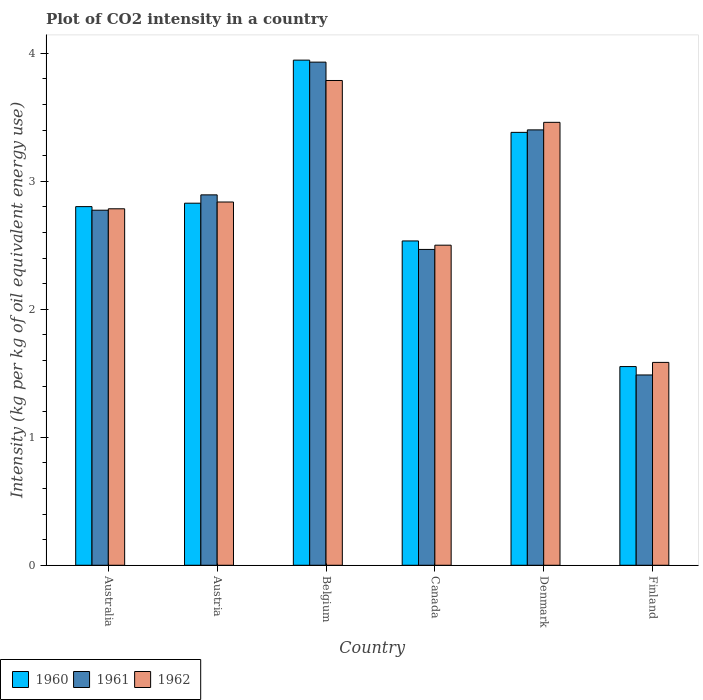Are the number of bars on each tick of the X-axis equal?
Your answer should be very brief. Yes. How many bars are there on the 1st tick from the left?
Your answer should be compact. 3. What is the label of the 5th group of bars from the left?
Provide a succinct answer. Denmark. In how many cases, is the number of bars for a given country not equal to the number of legend labels?
Offer a very short reply. 0. What is the CO2 intensity in in 1961 in Denmark?
Offer a terse response. 3.4. Across all countries, what is the maximum CO2 intensity in in 1962?
Provide a short and direct response. 3.79. Across all countries, what is the minimum CO2 intensity in in 1960?
Make the answer very short. 1.55. In which country was the CO2 intensity in in 1961 maximum?
Provide a succinct answer. Belgium. What is the total CO2 intensity in in 1962 in the graph?
Give a very brief answer. 16.95. What is the difference between the CO2 intensity in in 1962 in Belgium and that in Canada?
Offer a very short reply. 1.29. What is the difference between the CO2 intensity in in 1960 in Australia and the CO2 intensity in in 1961 in Canada?
Make the answer very short. 0.33. What is the average CO2 intensity in in 1961 per country?
Ensure brevity in your answer.  2.83. What is the difference between the CO2 intensity in of/in 1961 and CO2 intensity in of/in 1962 in Belgium?
Your response must be concise. 0.14. In how many countries, is the CO2 intensity in in 1961 greater than 0.6000000000000001 kg?
Provide a succinct answer. 6. What is the ratio of the CO2 intensity in in 1960 in Canada to that in Finland?
Offer a terse response. 1.63. Is the CO2 intensity in in 1962 in Australia less than that in Belgium?
Offer a very short reply. Yes. What is the difference between the highest and the second highest CO2 intensity in in 1962?
Provide a succinct answer. 0.62. What is the difference between the highest and the lowest CO2 intensity in in 1961?
Ensure brevity in your answer.  2.44. Is the sum of the CO2 intensity in in 1962 in Austria and Finland greater than the maximum CO2 intensity in in 1960 across all countries?
Your answer should be compact. Yes. What does the 1st bar from the left in Australia represents?
Your answer should be compact. 1960. What does the 3rd bar from the right in Finland represents?
Give a very brief answer. 1960. Is it the case that in every country, the sum of the CO2 intensity in in 1962 and CO2 intensity in in 1961 is greater than the CO2 intensity in in 1960?
Keep it short and to the point. Yes. Are all the bars in the graph horizontal?
Your response must be concise. No. What is the difference between two consecutive major ticks on the Y-axis?
Your answer should be compact. 1. Are the values on the major ticks of Y-axis written in scientific E-notation?
Your response must be concise. No. Does the graph contain any zero values?
Your answer should be compact. No. Where does the legend appear in the graph?
Keep it short and to the point. Bottom left. How many legend labels are there?
Offer a terse response. 3. How are the legend labels stacked?
Make the answer very short. Horizontal. What is the title of the graph?
Your answer should be compact. Plot of CO2 intensity in a country. Does "1968" appear as one of the legend labels in the graph?
Offer a terse response. No. What is the label or title of the X-axis?
Provide a short and direct response. Country. What is the label or title of the Y-axis?
Ensure brevity in your answer.  Intensity (kg per kg of oil equivalent energy use). What is the Intensity (kg per kg of oil equivalent energy use) in 1960 in Australia?
Your answer should be very brief. 2.8. What is the Intensity (kg per kg of oil equivalent energy use) of 1961 in Australia?
Keep it short and to the point. 2.77. What is the Intensity (kg per kg of oil equivalent energy use) of 1962 in Australia?
Your answer should be compact. 2.78. What is the Intensity (kg per kg of oil equivalent energy use) in 1960 in Austria?
Keep it short and to the point. 2.83. What is the Intensity (kg per kg of oil equivalent energy use) in 1961 in Austria?
Give a very brief answer. 2.89. What is the Intensity (kg per kg of oil equivalent energy use) of 1962 in Austria?
Offer a very short reply. 2.84. What is the Intensity (kg per kg of oil equivalent energy use) in 1960 in Belgium?
Offer a very short reply. 3.95. What is the Intensity (kg per kg of oil equivalent energy use) in 1961 in Belgium?
Your response must be concise. 3.93. What is the Intensity (kg per kg of oil equivalent energy use) of 1962 in Belgium?
Provide a short and direct response. 3.79. What is the Intensity (kg per kg of oil equivalent energy use) in 1960 in Canada?
Your answer should be compact. 2.53. What is the Intensity (kg per kg of oil equivalent energy use) of 1961 in Canada?
Your answer should be compact. 2.47. What is the Intensity (kg per kg of oil equivalent energy use) in 1962 in Canada?
Your response must be concise. 2.5. What is the Intensity (kg per kg of oil equivalent energy use) in 1960 in Denmark?
Your answer should be compact. 3.38. What is the Intensity (kg per kg of oil equivalent energy use) in 1961 in Denmark?
Make the answer very short. 3.4. What is the Intensity (kg per kg of oil equivalent energy use) of 1962 in Denmark?
Provide a short and direct response. 3.46. What is the Intensity (kg per kg of oil equivalent energy use) in 1960 in Finland?
Ensure brevity in your answer.  1.55. What is the Intensity (kg per kg of oil equivalent energy use) in 1961 in Finland?
Give a very brief answer. 1.49. What is the Intensity (kg per kg of oil equivalent energy use) of 1962 in Finland?
Offer a terse response. 1.58. Across all countries, what is the maximum Intensity (kg per kg of oil equivalent energy use) of 1960?
Keep it short and to the point. 3.95. Across all countries, what is the maximum Intensity (kg per kg of oil equivalent energy use) in 1961?
Keep it short and to the point. 3.93. Across all countries, what is the maximum Intensity (kg per kg of oil equivalent energy use) in 1962?
Offer a terse response. 3.79. Across all countries, what is the minimum Intensity (kg per kg of oil equivalent energy use) in 1960?
Your answer should be very brief. 1.55. Across all countries, what is the minimum Intensity (kg per kg of oil equivalent energy use) of 1961?
Keep it short and to the point. 1.49. Across all countries, what is the minimum Intensity (kg per kg of oil equivalent energy use) of 1962?
Offer a terse response. 1.58. What is the total Intensity (kg per kg of oil equivalent energy use) in 1960 in the graph?
Offer a terse response. 17.04. What is the total Intensity (kg per kg of oil equivalent energy use) of 1961 in the graph?
Offer a very short reply. 16.95. What is the total Intensity (kg per kg of oil equivalent energy use) in 1962 in the graph?
Provide a short and direct response. 16.95. What is the difference between the Intensity (kg per kg of oil equivalent energy use) in 1960 in Australia and that in Austria?
Offer a very short reply. -0.03. What is the difference between the Intensity (kg per kg of oil equivalent energy use) of 1961 in Australia and that in Austria?
Give a very brief answer. -0.12. What is the difference between the Intensity (kg per kg of oil equivalent energy use) of 1962 in Australia and that in Austria?
Your answer should be compact. -0.05. What is the difference between the Intensity (kg per kg of oil equivalent energy use) in 1960 in Australia and that in Belgium?
Ensure brevity in your answer.  -1.14. What is the difference between the Intensity (kg per kg of oil equivalent energy use) of 1961 in Australia and that in Belgium?
Give a very brief answer. -1.16. What is the difference between the Intensity (kg per kg of oil equivalent energy use) of 1962 in Australia and that in Belgium?
Provide a succinct answer. -1. What is the difference between the Intensity (kg per kg of oil equivalent energy use) of 1960 in Australia and that in Canada?
Offer a terse response. 0.27. What is the difference between the Intensity (kg per kg of oil equivalent energy use) in 1961 in Australia and that in Canada?
Keep it short and to the point. 0.31. What is the difference between the Intensity (kg per kg of oil equivalent energy use) of 1962 in Australia and that in Canada?
Ensure brevity in your answer.  0.28. What is the difference between the Intensity (kg per kg of oil equivalent energy use) of 1960 in Australia and that in Denmark?
Offer a very short reply. -0.58. What is the difference between the Intensity (kg per kg of oil equivalent energy use) of 1961 in Australia and that in Denmark?
Your response must be concise. -0.63. What is the difference between the Intensity (kg per kg of oil equivalent energy use) in 1962 in Australia and that in Denmark?
Offer a terse response. -0.68. What is the difference between the Intensity (kg per kg of oil equivalent energy use) in 1960 in Australia and that in Finland?
Ensure brevity in your answer.  1.25. What is the difference between the Intensity (kg per kg of oil equivalent energy use) in 1961 in Australia and that in Finland?
Offer a terse response. 1.29. What is the difference between the Intensity (kg per kg of oil equivalent energy use) of 1960 in Austria and that in Belgium?
Provide a short and direct response. -1.12. What is the difference between the Intensity (kg per kg of oil equivalent energy use) of 1961 in Austria and that in Belgium?
Provide a short and direct response. -1.04. What is the difference between the Intensity (kg per kg of oil equivalent energy use) of 1962 in Austria and that in Belgium?
Offer a terse response. -0.95. What is the difference between the Intensity (kg per kg of oil equivalent energy use) of 1960 in Austria and that in Canada?
Ensure brevity in your answer.  0.29. What is the difference between the Intensity (kg per kg of oil equivalent energy use) in 1961 in Austria and that in Canada?
Provide a short and direct response. 0.43. What is the difference between the Intensity (kg per kg of oil equivalent energy use) in 1962 in Austria and that in Canada?
Your answer should be very brief. 0.34. What is the difference between the Intensity (kg per kg of oil equivalent energy use) in 1960 in Austria and that in Denmark?
Offer a terse response. -0.55. What is the difference between the Intensity (kg per kg of oil equivalent energy use) in 1961 in Austria and that in Denmark?
Offer a very short reply. -0.51. What is the difference between the Intensity (kg per kg of oil equivalent energy use) in 1962 in Austria and that in Denmark?
Give a very brief answer. -0.62. What is the difference between the Intensity (kg per kg of oil equivalent energy use) in 1960 in Austria and that in Finland?
Your answer should be compact. 1.28. What is the difference between the Intensity (kg per kg of oil equivalent energy use) of 1961 in Austria and that in Finland?
Ensure brevity in your answer.  1.41. What is the difference between the Intensity (kg per kg of oil equivalent energy use) in 1962 in Austria and that in Finland?
Offer a very short reply. 1.25. What is the difference between the Intensity (kg per kg of oil equivalent energy use) of 1960 in Belgium and that in Canada?
Ensure brevity in your answer.  1.41. What is the difference between the Intensity (kg per kg of oil equivalent energy use) of 1961 in Belgium and that in Canada?
Give a very brief answer. 1.46. What is the difference between the Intensity (kg per kg of oil equivalent energy use) in 1962 in Belgium and that in Canada?
Provide a short and direct response. 1.29. What is the difference between the Intensity (kg per kg of oil equivalent energy use) of 1960 in Belgium and that in Denmark?
Keep it short and to the point. 0.56. What is the difference between the Intensity (kg per kg of oil equivalent energy use) in 1961 in Belgium and that in Denmark?
Your response must be concise. 0.53. What is the difference between the Intensity (kg per kg of oil equivalent energy use) in 1962 in Belgium and that in Denmark?
Offer a very short reply. 0.33. What is the difference between the Intensity (kg per kg of oil equivalent energy use) of 1960 in Belgium and that in Finland?
Your answer should be compact. 2.39. What is the difference between the Intensity (kg per kg of oil equivalent energy use) of 1961 in Belgium and that in Finland?
Your answer should be very brief. 2.44. What is the difference between the Intensity (kg per kg of oil equivalent energy use) in 1962 in Belgium and that in Finland?
Ensure brevity in your answer.  2.2. What is the difference between the Intensity (kg per kg of oil equivalent energy use) of 1960 in Canada and that in Denmark?
Your answer should be compact. -0.85. What is the difference between the Intensity (kg per kg of oil equivalent energy use) in 1961 in Canada and that in Denmark?
Your answer should be very brief. -0.93. What is the difference between the Intensity (kg per kg of oil equivalent energy use) of 1962 in Canada and that in Denmark?
Provide a short and direct response. -0.96. What is the difference between the Intensity (kg per kg of oil equivalent energy use) in 1960 in Canada and that in Finland?
Provide a short and direct response. 0.98. What is the difference between the Intensity (kg per kg of oil equivalent energy use) of 1961 in Canada and that in Finland?
Keep it short and to the point. 0.98. What is the difference between the Intensity (kg per kg of oil equivalent energy use) in 1962 in Canada and that in Finland?
Ensure brevity in your answer.  0.92. What is the difference between the Intensity (kg per kg of oil equivalent energy use) in 1960 in Denmark and that in Finland?
Your answer should be compact. 1.83. What is the difference between the Intensity (kg per kg of oil equivalent energy use) of 1961 in Denmark and that in Finland?
Your answer should be very brief. 1.91. What is the difference between the Intensity (kg per kg of oil equivalent energy use) in 1962 in Denmark and that in Finland?
Give a very brief answer. 1.88. What is the difference between the Intensity (kg per kg of oil equivalent energy use) in 1960 in Australia and the Intensity (kg per kg of oil equivalent energy use) in 1961 in Austria?
Your response must be concise. -0.09. What is the difference between the Intensity (kg per kg of oil equivalent energy use) of 1960 in Australia and the Intensity (kg per kg of oil equivalent energy use) of 1962 in Austria?
Make the answer very short. -0.04. What is the difference between the Intensity (kg per kg of oil equivalent energy use) in 1961 in Australia and the Intensity (kg per kg of oil equivalent energy use) in 1962 in Austria?
Your answer should be compact. -0.06. What is the difference between the Intensity (kg per kg of oil equivalent energy use) of 1960 in Australia and the Intensity (kg per kg of oil equivalent energy use) of 1961 in Belgium?
Make the answer very short. -1.13. What is the difference between the Intensity (kg per kg of oil equivalent energy use) of 1960 in Australia and the Intensity (kg per kg of oil equivalent energy use) of 1962 in Belgium?
Provide a short and direct response. -0.99. What is the difference between the Intensity (kg per kg of oil equivalent energy use) of 1961 in Australia and the Intensity (kg per kg of oil equivalent energy use) of 1962 in Belgium?
Offer a very short reply. -1.01. What is the difference between the Intensity (kg per kg of oil equivalent energy use) in 1960 in Australia and the Intensity (kg per kg of oil equivalent energy use) in 1961 in Canada?
Provide a short and direct response. 0.33. What is the difference between the Intensity (kg per kg of oil equivalent energy use) of 1960 in Australia and the Intensity (kg per kg of oil equivalent energy use) of 1962 in Canada?
Your answer should be very brief. 0.3. What is the difference between the Intensity (kg per kg of oil equivalent energy use) in 1961 in Australia and the Intensity (kg per kg of oil equivalent energy use) in 1962 in Canada?
Your answer should be very brief. 0.27. What is the difference between the Intensity (kg per kg of oil equivalent energy use) in 1960 in Australia and the Intensity (kg per kg of oil equivalent energy use) in 1961 in Denmark?
Offer a terse response. -0.6. What is the difference between the Intensity (kg per kg of oil equivalent energy use) in 1960 in Australia and the Intensity (kg per kg of oil equivalent energy use) in 1962 in Denmark?
Ensure brevity in your answer.  -0.66. What is the difference between the Intensity (kg per kg of oil equivalent energy use) of 1961 in Australia and the Intensity (kg per kg of oil equivalent energy use) of 1962 in Denmark?
Ensure brevity in your answer.  -0.69. What is the difference between the Intensity (kg per kg of oil equivalent energy use) in 1960 in Australia and the Intensity (kg per kg of oil equivalent energy use) in 1961 in Finland?
Keep it short and to the point. 1.32. What is the difference between the Intensity (kg per kg of oil equivalent energy use) of 1960 in Australia and the Intensity (kg per kg of oil equivalent energy use) of 1962 in Finland?
Offer a terse response. 1.22. What is the difference between the Intensity (kg per kg of oil equivalent energy use) in 1961 in Australia and the Intensity (kg per kg of oil equivalent energy use) in 1962 in Finland?
Make the answer very short. 1.19. What is the difference between the Intensity (kg per kg of oil equivalent energy use) in 1960 in Austria and the Intensity (kg per kg of oil equivalent energy use) in 1961 in Belgium?
Keep it short and to the point. -1.1. What is the difference between the Intensity (kg per kg of oil equivalent energy use) in 1960 in Austria and the Intensity (kg per kg of oil equivalent energy use) in 1962 in Belgium?
Your answer should be very brief. -0.96. What is the difference between the Intensity (kg per kg of oil equivalent energy use) in 1961 in Austria and the Intensity (kg per kg of oil equivalent energy use) in 1962 in Belgium?
Your answer should be very brief. -0.89. What is the difference between the Intensity (kg per kg of oil equivalent energy use) of 1960 in Austria and the Intensity (kg per kg of oil equivalent energy use) of 1961 in Canada?
Ensure brevity in your answer.  0.36. What is the difference between the Intensity (kg per kg of oil equivalent energy use) of 1960 in Austria and the Intensity (kg per kg of oil equivalent energy use) of 1962 in Canada?
Your response must be concise. 0.33. What is the difference between the Intensity (kg per kg of oil equivalent energy use) of 1961 in Austria and the Intensity (kg per kg of oil equivalent energy use) of 1962 in Canada?
Offer a terse response. 0.39. What is the difference between the Intensity (kg per kg of oil equivalent energy use) in 1960 in Austria and the Intensity (kg per kg of oil equivalent energy use) in 1961 in Denmark?
Your answer should be compact. -0.57. What is the difference between the Intensity (kg per kg of oil equivalent energy use) in 1960 in Austria and the Intensity (kg per kg of oil equivalent energy use) in 1962 in Denmark?
Provide a short and direct response. -0.63. What is the difference between the Intensity (kg per kg of oil equivalent energy use) of 1961 in Austria and the Intensity (kg per kg of oil equivalent energy use) of 1962 in Denmark?
Your answer should be very brief. -0.57. What is the difference between the Intensity (kg per kg of oil equivalent energy use) of 1960 in Austria and the Intensity (kg per kg of oil equivalent energy use) of 1961 in Finland?
Ensure brevity in your answer.  1.34. What is the difference between the Intensity (kg per kg of oil equivalent energy use) of 1960 in Austria and the Intensity (kg per kg of oil equivalent energy use) of 1962 in Finland?
Provide a succinct answer. 1.24. What is the difference between the Intensity (kg per kg of oil equivalent energy use) of 1961 in Austria and the Intensity (kg per kg of oil equivalent energy use) of 1962 in Finland?
Make the answer very short. 1.31. What is the difference between the Intensity (kg per kg of oil equivalent energy use) in 1960 in Belgium and the Intensity (kg per kg of oil equivalent energy use) in 1961 in Canada?
Ensure brevity in your answer.  1.48. What is the difference between the Intensity (kg per kg of oil equivalent energy use) of 1960 in Belgium and the Intensity (kg per kg of oil equivalent energy use) of 1962 in Canada?
Make the answer very short. 1.45. What is the difference between the Intensity (kg per kg of oil equivalent energy use) in 1961 in Belgium and the Intensity (kg per kg of oil equivalent energy use) in 1962 in Canada?
Your answer should be compact. 1.43. What is the difference between the Intensity (kg per kg of oil equivalent energy use) in 1960 in Belgium and the Intensity (kg per kg of oil equivalent energy use) in 1961 in Denmark?
Provide a short and direct response. 0.54. What is the difference between the Intensity (kg per kg of oil equivalent energy use) in 1960 in Belgium and the Intensity (kg per kg of oil equivalent energy use) in 1962 in Denmark?
Make the answer very short. 0.49. What is the difference between the Intensity (kg per kg of oil equivalent energy use) in 1961 in Belgium and the Intensity (kg per kg of oil equivalent energy use) in 1962 in Denmark?
Give a very brief answer. 0.47. What is the difference between the Intensity (kg per kg of oil equivalent energy use) of 1960 in Belgium and the Intensity (kg per kg of oil equivalent energy use) of 1961 in Finland?
Offer a terse response. 2.46. What is the difference between the Intensity (kg per kg of oil equivalent energy use) in 1960 in Belgium and the Intensity (kg per kg of oil equivalent energy use) in 1962 in Finland?
Your answer should be compact. 2.36. What is the difference between the Intensity (kg per kg of oil equivalent energy use) of 1961 in Belgium and the Intensity (kg per kg of oil equivalent energy use) of 1962 in Finland?
Your answer should be very brief. 2.35. What is the difference between the Intensity (kg per kg of oil equivalent energy use) of 1960 in Canada and the Intensity (kg per kg of oil equivalent energy use) of 1961 in Denmark?
Your answer should be compact. -0.87. What is the difference between the Intensity (kg per kg of oil equivalent energy use) of 1960 in Canada and the Intensity (kg per kg of oil equivalent energy use) of 1962 in Denmark?
Give a very brief answer. -0.93. What is the difference between the Intensity (kg per kg of oil equivalent energy use) in 1961 in Canada and the Intensity (kg per kg of oil equivalent energy use) in 1962 in Denmark?
Your response must be concise. -0.99. What is the difference between the Intensity (kg per kg of oil equivalent energy use) of 1960 in Canada and the Intensity (kg per kg of oil equivalent energy use) of 1961 in Finland?
Keep it short and to the point. 1.05. What is the difference between the Intensity (kg per kg of oil equivalent energy use) of 1960 in Canada and the Intensity (kg per kg of oil equivalent energy use) of 1962 in Finland?
Your answer should be compact. 0.95. What is the difference between the Intensity (kg per kg of oil equivalent energy use) of 1961 in Canada and the Intensity (kg per kg of oil equivalent energy use) of 1962 in Finland?
Provide a short and direct response. 0.88. What is the difference between the Intensity (kg per kg of oil equivalent energy use) in 1960 in Denmark and the Intensity (kg per kg of oil equivalent energy use) in 1961 in Finland?
Give a very brief answer. 1.9. What is the difference between the Intensity (kg per kg of oil equivalent energy use) in 1960 in Denmark and the Intensity (kg per kg of oil equivalent energy use) in 1962 in Finland?
Your answer should be compact. 1.8. What is the difference between the Intensity (kg per kg of oil equivalent energy use) in 1961 in Denmark and the Intensity (kg per kg of oil equivalent energy use) in 1962 in Finland?
Your response must be concise. 1.82. What is the average Intensity (kg per kg of oil equivalent energy use) in 1960 per country?
Give a very brief answer. 2.84. What is the average Intensity (kg per kg of oil equivalent energy use) of 1961 per country?
Ensure brevity in your answer.  2.83. What is the average Intensity (kg per kg of oil equivalent energy use) of 1962 per country?
Keep it short and to the point. 2.83. What is the difference between the Intensity (kg per kg of oil equivalent energy use) of 1960 and Intensity (kg per kg of oil equivalent energy use) of 1961 in Australia?
Give a very brief answer. 0.03. What is the difference between the Intensity (kg per kg of oil equivalent energy use) in 1960 and Intensity (kg per kg of oil equivalent energy use) in 1962 in Australia?
Offer a very short reply. 0.02. What is the difference between the Intensity (kg per kg of oil equivalent energy use) of 1961 and Intensity (kg per kg of oil equivalent energy use) of 1962 in Australia?
Make the answer very short. -0.01. What is the difference between the Intensity (kg per kg of oil equivalent energy use) of 1960 and Intensity (kg per kg of oil equivalent energy use) of 1961 in Austria?
Offer a terse response. -0.07. What is the difference between the Intensity (kg per kg of oil equivalent energy use) in 1960 and Intensity (kg per kg of oil equivalent energy use) in 1962 in Austria?
Make the answer very short. -0.01. What is the difference between the Intensity (kg per kg of oil equivalent energy use) in 1961 and Intensity (kg per kg of oil equivalent energy use) in 1962 in Austria?
Your answer should be compact. 0.06. What is the difference between the Intensity (kg per kg of oil equivalent energy use) in 1960 and Intensity (kg per kg of oil equivalent energy use) in 1961 in Belgium?
Your answer should be compact. 0.02. What is the difference between the Intensity (kg per kg of oil equivalent energy use) in 1960 and Intensity (kg per kg of oil equivalent energy use) in 1962 in Belgium?
Provide a succinct answer. 0.16. What is the difference between the Intensity (kg per kg of oil equivalent energy use) in 1961 and Intensity (kg per kg of oil equivalent energy use) in 1962 in Belgium?
Keep it short and to the point. 0.14. What is the difference between the Intensity (kg per kg of oil equivalent energy use) in 1960 and Intensity (kg per kg of oil equivalent energy use) in 1961 in Canada?
Make the answer very short. 0.07. What is the difference between the Intensity (kg per kg of oil equivalent energy use) in 1960 and Intensity (kg per kg of oil equivalent energy use) in 1962 in Canada?
Offer a very short reply. 0.03. What is the difference between the Intensity (kg per kg of oil equivalent energy use) in 1961 and Intensity (kg per kg of oil equivalent energy use) in 1962 in Canada?
Your answer should be compact. -0.03. What is the difference between the Intensity (kg per kg of oil equivalent energy use) in 1960 and Intensity (kg per kg of oil equivalent energy use) in 1961 in Denmark?
Your answer should be very brief. -0.02. What is the difference between the Intensity (kg per kg of oil equivalent energy use) in 1960 and Intensity (kg per kg of oil equivalent energy use) in 1962 in Denmark?
Offer a terse response. -0.08. What is the difference between the Intensity (kg per kg of oil equivalent energy use) in 1961 and Intensity (kg per kg of oil equivalent energy use) in 1962 in Denmark?
Offer a terse response. -0.06. What is the difference between the Intensity (kg per kg of oil equivalent energy use) of 1960 and Intensity (kg per kg of oil equivalent energy use) of 1961 in Finland?
Provide a short and direct response. 0.07. What is the difference between the Intensity (kg per kg of oil equivalent energy use) in 1960 and Intensity (kg per kg of oil equivalent energy use) in 1962 in Finland?
Offer a very short reply. -0.03. What is the difference between the Intensity (kg per kg of oil equivalent energy use) of 1961 and Intensity (kg per kg of oil equivalent energy use) of 1962 in Finland?
Offer a terse response. -0.1. What is the ratio of the Intensity (kg per kg of oil equivalent energy use) of 1960 in Australia to that in Austria?
Provide a succinct answer. 0.99. What is the ratio of the Intensity (kg per kg of oil equivalent energy use) in 1961 in Australia to that in Austria?
Give a very brief answer. 0.96. What is the ratio of the Intensity (kg per kg of oil equivalent energy use) of 1962 in Australia to that in Austria?
Make the answer very short. 0.98. What is the ratio of the Intensity (kg per kg of oil equivalent energy use) of 1960 in Australia to that in Belgium?
Offer a terse response. 0.71. What is the ratio of the Intensity (kg per kg of oil equivalent energy use) in 1961 in Australia to that in Belgium?
Offer a terse response. 0.71. What is the ratio of the Intensity (kg per kg of oil equivalent energy use) in 1962 in Australia to that in Belgium?
Offer a terse response. 0.74. What is the ratio of the Intensity (kg per kg of oil equivalent energy use) of 1960 in Australia to that in Canada?
Your answer should be compact. 1.11. What is the ratio of the Intensity (kg per kg of oil equivalent energy use) of 1961 in Australia to that in Canada?
Make the answer very short. 1.12. What is the ratio of the Intensity (kg per kg of oil equivalent energy use) of 1962 in Australia to that in Canada?
Give a very brief answer. 1.11. What is the ratio of the Intensity (kg per kg of oil equivalent energy use) in 1960 in Australia to that in Denmark?
Your response must be concise. 0.83. What is the ratio of the Intensity (kg per kg of oil equivalent energy use) of 1961 in Australia to that in Denmark?
Provide a short and direct response. 0.82. What is the ratio of the Intensity (kg per kg of oil equivalent energy use) of 1962 in Australia to that in Denmark?
Your response must be concise. 0.8. What is the ratio of the Intensity (kg per kg of oil equivalent energy use) of 1960 in Australia to that in Finland?
Your answer should be very brief. 1.81. What is the ratio of the Intensity (kg per kg of oil equivalent energy use) of 1961 in Australia to that in Finland?
Give a very brief answer. 1.87. What is the ratio of the Intensity (kg per kg of oil equivalent energy use) in 1962 in Australia to that in Finland?
Offer a very short reply. 1.76. What is the ratio of the Intensity (kg per kg of oil equivalent energy use) of 1960 in Austria to that in Belgium?
Give a very brief answer. 0.72. What is the ratio of the Intensity (kg per kg of oil equivalent energy use) in 1961 in Austria to that in Belgium?
Offer a very short reply. 0.74. What is the ratio of the Intensity (kg per kg of oil equivalent energy use) of 1962 in Austria to that in Belgium?
Your answer should be very brief. 0.75. What is the ratio of the Intensity (kg per kg of oil equivalent energy use) of 1960 in Austria to that in Canada?
Provide a succinct answer. 1.12. What is the ratio of the Intensity (kg per kg of oil equivalent energy use) of 1961 in Austria to that in Canada?
Ensure brevity in your answer.  1.17. What is the ratio of the Intensity (kg per kg of oil equivalent energy use) of 1962 in Austria to that in Canada?
Your response must be concise. 1.13. What is the ratio of the Intensity (kg per kg of oil equivalent energy use) of 1960 in Austria to that in Denmark?
Provide a succinct answer. 0.84. What is the ratio of the Intensity (kg per kg of oil equivalent energy use) of 1961 in Austria to that in Denmark?
Your answer should be very brief. 0.85. What is the ratio of the Intensity (kg per kg of oil equivalent energy use) of 1962 in Austria to that in Denmark?
Ensure brevity in your answer.  0.82. What is the ratio of the Intensity (kg per kg of oil equivalent energy use) in 1960 in Austria to that in Finland?
Your answer should be very brief. 1.82. What is the ratio of the Intensity (kg per kg of oil equivalent energy use) in 1961 in Austria to that in Finland?
Provide a succinct answer. 1.95. What is the ratio of the Intensity (kg per kg of oil equivalent energy use) of 1962 in Austria to that in Finland?
Make the answer very short. 1.79. What is the ratio of the Intensity (kg per kg of oil equivalent energy use) in 1960 in Belgium to that in Canada?
Your response must be concise. 1.56. What is the ratio of the Intensity (kg per kg of oil equivalent energy use) in 1961 in Belgium to that in Canada?
Your answer should be very brief. 1.59. What is the ratio of the Intensity (kg per kg of oil equivalent energy use) in 1962 in Belgium to that in Canada?
Provide a succinct answer. 1.51. What is the ratio of the Intensity (kg per kg of oil equivalent energy use) in 1960 in Belgium to that in Denmark?
Your response must be concise. 1.17. What is the ratio of the Intensity (kg per kg of oil equivalent energy use) in 1961 in Belgium to that in Denmark?
Give a very brief answer. 1.16. What is the ratio of the Intensity (kg per kg of oil equivalent energy use) of 1962 in Belgium to that in Denmark?
Your answer should be compact. 1.09. What is the ratio of the Intensity (kg per kg of oil equivalent energy use) of 1960 in Belgium to that in Finland?
Provide a succinct answer. 2.54. What is the ratio of the Intensity (kg per kg of oil equivalent energy use) in 1961 in Belgium to that in Finland?
Ensure brevity in your answer.  2.64. What is the ratio of the Intensity (kg per kg of oil equivalent energy use) of 1962 in Belgium to that in Finland?
Offer a terse response. 2.39. What is the ratio of the Intensity (kg per kg of oil equivalent energy use) in 1960 in Canada to that in Denmark?
Your answer should be compact. 0.75. What is the ratio of the Intensity (kg per kg of oil equivalent energy use) in 1961 in Canada to that in Denmark?
Make the answer very short. 0.73. What is the ratio of the Intensity (kg per kg of oil equivalent energy use) in 1962 in Canada to that in Denmark?
Provide a succinct answer. 0.72. What is the ratio of the Intensity (kg per kg of oil equivalent energy use) of 1960 in Canada to that in Finland?
Offer a terse response. 1.63. What is the ratio of the Intensity (kg per kg of oil equivalent energy use) in 1961 in Canada to that in Finland?
Your response must be concise. 1.66. What is the ratio of the Intensity (kg per kg of oil equivalent energy use) in 1962 in Canada to that in Finland?
Your response must be concise. 1.58. What is the ratio of the Intensity (kg per kg of oil equivalent energy use) of 1960 in Denmark to that in Finland?
Give a very brief answer. 2.18. What is the ratio of the Intensity (kg per kg of oil equivalent energy use) of 1961 in Denmark to that in Finland?
Keep it short and to the point. 2.29. What is the ratio of the Intensity (kg per kg of oil equivalent energy use) of 1962 in Denmark to that in Finland?
Offer a terse response. 2.18. What is the difference between the highest and the second highest Intensity (kg per kg of oil equivalent energy use) of 1960?
Offer a very short reply. 0.56. What is the difference between the highest and the second highest Intensity (kg per kg of oil equivalent energy use) in 1961?
Offer a terse response. 0.53. What is the difference between the highest and the second highest Intensity (kg per kg of oil equivalent energy use) of 1962?
Your answer should be very brief. 0.33. What is the difference between the highest and the lowest Intensity (kg per kg of oil equivalent energy use) in 1960?
Ensure brevity in your answer.  2.39. What is the difference between the highest and the lowest Intensity (kg per kg of oil equivalent energy use) in 1961?
Provide a short and direct response. 2.44. What is the difference between the highest and the lowest Intensity (kg per kg of oil equivalent energy use) of 1962?
Your response must be concise. 2.2. 